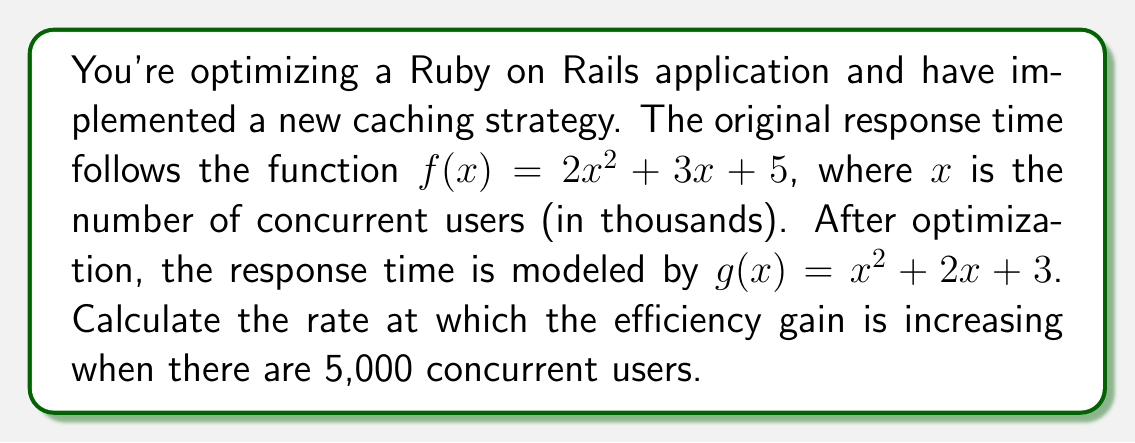Help me with this question. To solve this problem, we need to follow these steps:

1) First, let's define the efficiency gain function. It's the difference between the original and optimized response times:
   $h(x) = f(x) - g(x) = (2x^2 + 3x + 5) - (x^2 + 2x + 3) = x^2 + x + 2$

2) To find the rate at which the efficiency gain is increasing, we need to find the derivative of $h(x)$:
   $h'(x) = 2x + 1$

3) Now, we need to evaluate this at $x = 5$ (since 5,000 users = 5 in our scale of thousands):
   $h'(5) = 2(5) + 1 = 10 + 1 = 11$

4) This means that when there are 5,000 concurrent users, the efficiency gain is increasing at a rate of 11 milliseconds per 1,000 additional users.
Answer: 11 ms/1000 users 